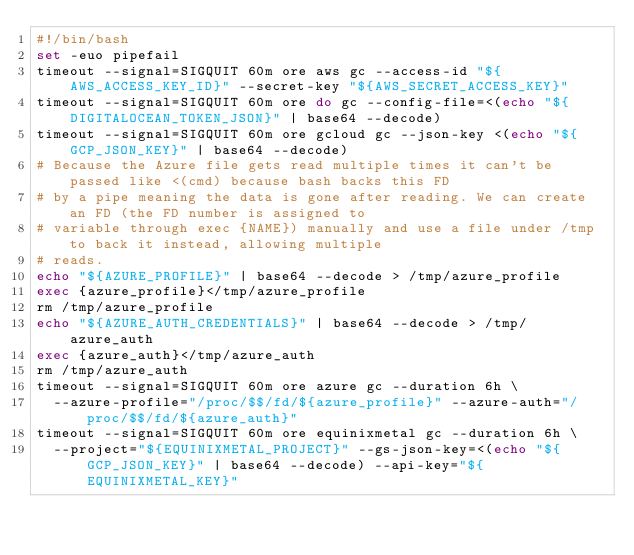<code> <loc_0><loc_0><loc_500><loc_500><_Bash_>#!/bin/bash
set -euo pipefail
timeout --signal=SIGQUIT 60m ore aws gc --access-id "${AWS_ACCESS_KEY_ID}" --secret-key "${AWS_SECRET_ACCESS_KEY}"
timeout --signal=SIGQUIT 60m ore do gc --config-file=<(echo "${DIGITALOCEAN_TOKEN_JSON}" | base64 --decode)
timeout --signal=SIGQUIT 60m ore gcloud gc --json-key <(echo "${GCP_JSON_KEY}" | base64 --decode)
# Because the Azure file gets read multiple times it can't be passed like <(cmd) because bash backs this FD
# by a pipe meaning the data is gone after reading. We can create an FD (the FD number is assigned to
# variable through exec {NAME}) manually and use a file under /tmp to back it instead, allowing multiple
# reads.
echo "${AZURE_PROFILE}" | base64 --decode > /tmp/azure_profile
exec {azure_profile}</tmp/azure_profile
rm /tmp/azure_profile
echo "${AZURE_AUTH_CREDENTIALS}" | base64 --decode > /tmp/azure_auth
exec {azure_auth}</tmp/azure_auth
rm /tmp/azure_auth
timeout --signal=SIGQUIT 60m ore azure gc --duration 6h \
  --azure-profile="/proc/$$/fd/${azure_profile}" --azure-auth="/proc/$$/fd/${azure_auth}"
timeout --signal=SIGQUIT 60m ore equinixmetal gc --duration 6h \
  --project="${EQUINIXMETAL_PROJECT}" --gs-json-key=<(echo "${GCP_JSON_KEY}" | base64 --decode) --api-key="${EQUINIXMETAL_KEY}"
</code> 